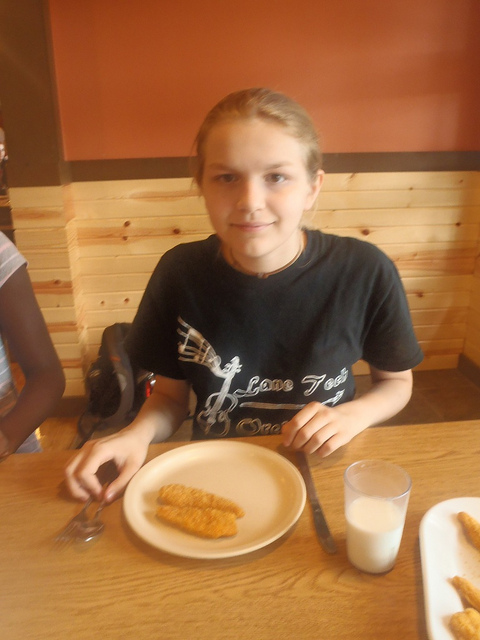Identify the text displayed in this image. Lane 